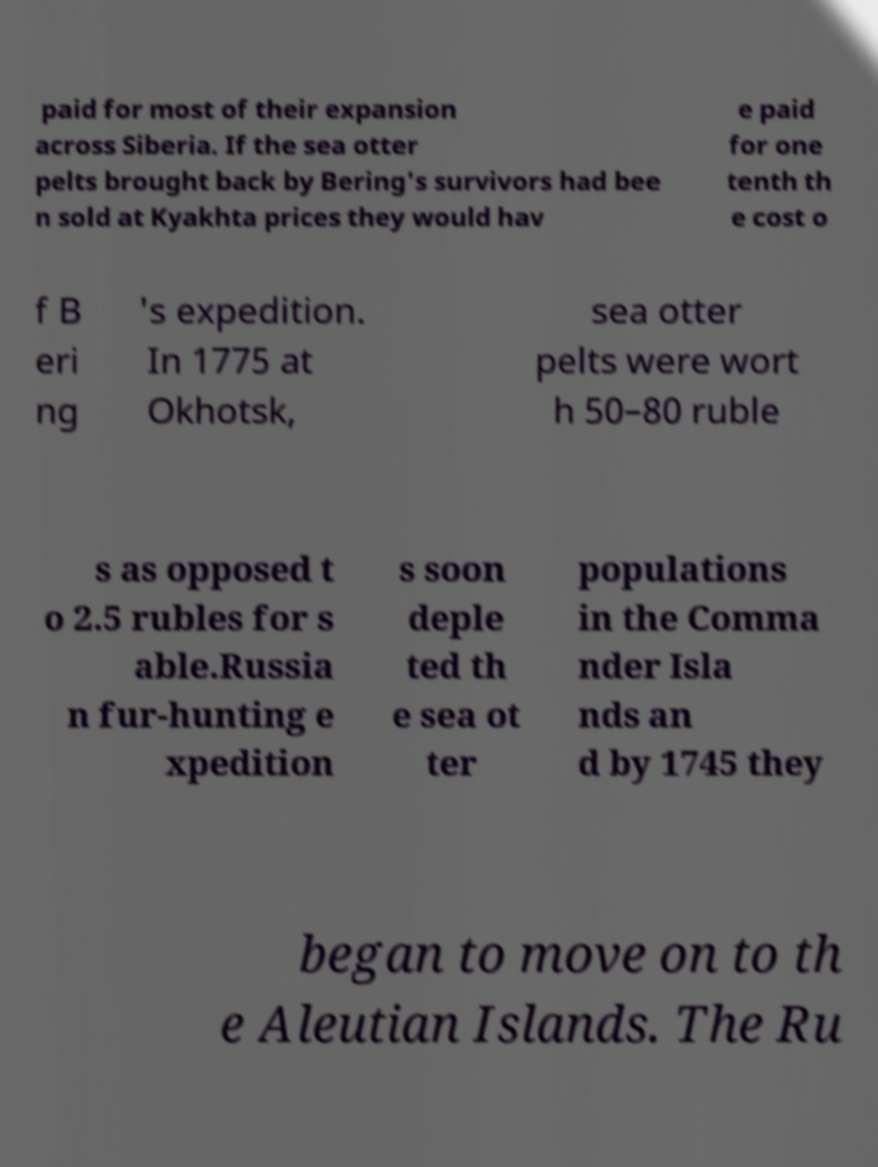Please read and relay the text visible in this image. What does it say? paid for most of their expansion across Siberia. If the sea otter pelts brought back by Bering's survivors had bee n sold at Kyakhta prices they would hav e paid for one tenth th e cost o f B eri ng 's expedition. In 1775 at Okhotsk, sea otter pelts were wort h 50–80 ruble s as opposed t o 2.5 rubles for s able.Russia n fur-hunting e xpedition s soon deple ted th e sea ot ter populations in the Comma nder Isla nds an d by 1745 they began to move on to th e Aleutian Islands. The Ru 